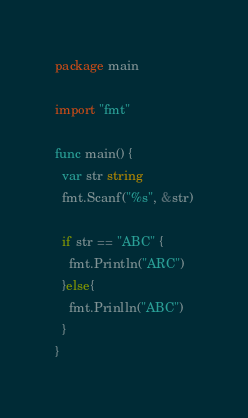<code> <loc_0><loc_0><loc_500><loc_500><_Go_>package main

import "fmt"

func main() {
  var str string
  fmt.Scanf("%s", &str)
  
  if str == "ABC" {
    fmt.Println("ARC")
  }else{
    fmt.Prinlln("ABC")
  }
}</code> 